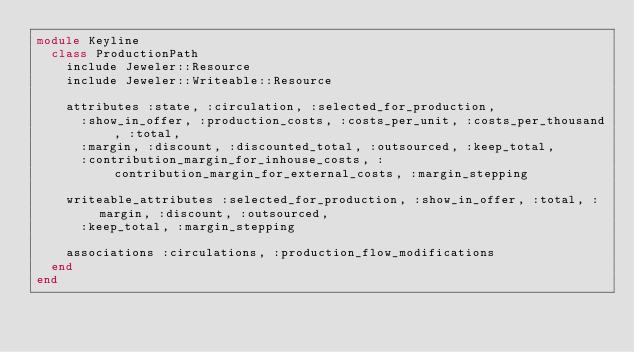Convert code to text. <code><loc_0><loc_0><loc_500><loc_500><_Ruby_>module Keyline
  class ProductionPath
    include Jeweler::Resource
    include Jeweler::Writeable::Resource

    attributes :state, :circulation, :selected_for_production,
      :show_in_offer, :production_costs, :costs_per_unit, :costs_per_thousand, :total,
      :margin, :discount, :discounted_total, :outsourced, :keep_total,
      :contribution_margin_for_inhouse_costs, :contribution_margin_for_external_costs, :margin_stepping

    writeable_attributes :selected_for_production, :show_in_offer, :total, :margin, :discount, :outsourced,
      :keep_total, :margin_stepping

    associations :circulations, :production_flow_modifications
  end
end
</code> 